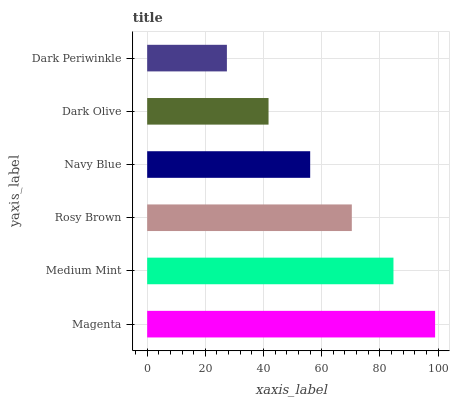Is Dark Periwinkle the minimum?
Answer yes or no. Yes. Is Magenta the maximum?
Answer yes or no. Yes. Is Medium Mint the minimum?
Answer yes or no. No. Is Medium Mint the maximum?
Answer yes or no. No. Is Magenta greater than Medium Mint?
Answer yes or no. Yes. Is Medium Mint less than Magenta?
Answer yes or no. Yes. Is Medium Mint greater than Magenta?
Answer yes or no. No. Is Magenta less than Medium Mint?
Answer yes or no. No. Is Rosy Brown the high median?
Answer yes or no. Yes. Is Navy Blue the low median?
Answer yes or no. Yes. Is Dark Periwinkle the high median?
Answer yes or no. No. Is Medium Mint the low median?
Answer yes or no. No. 